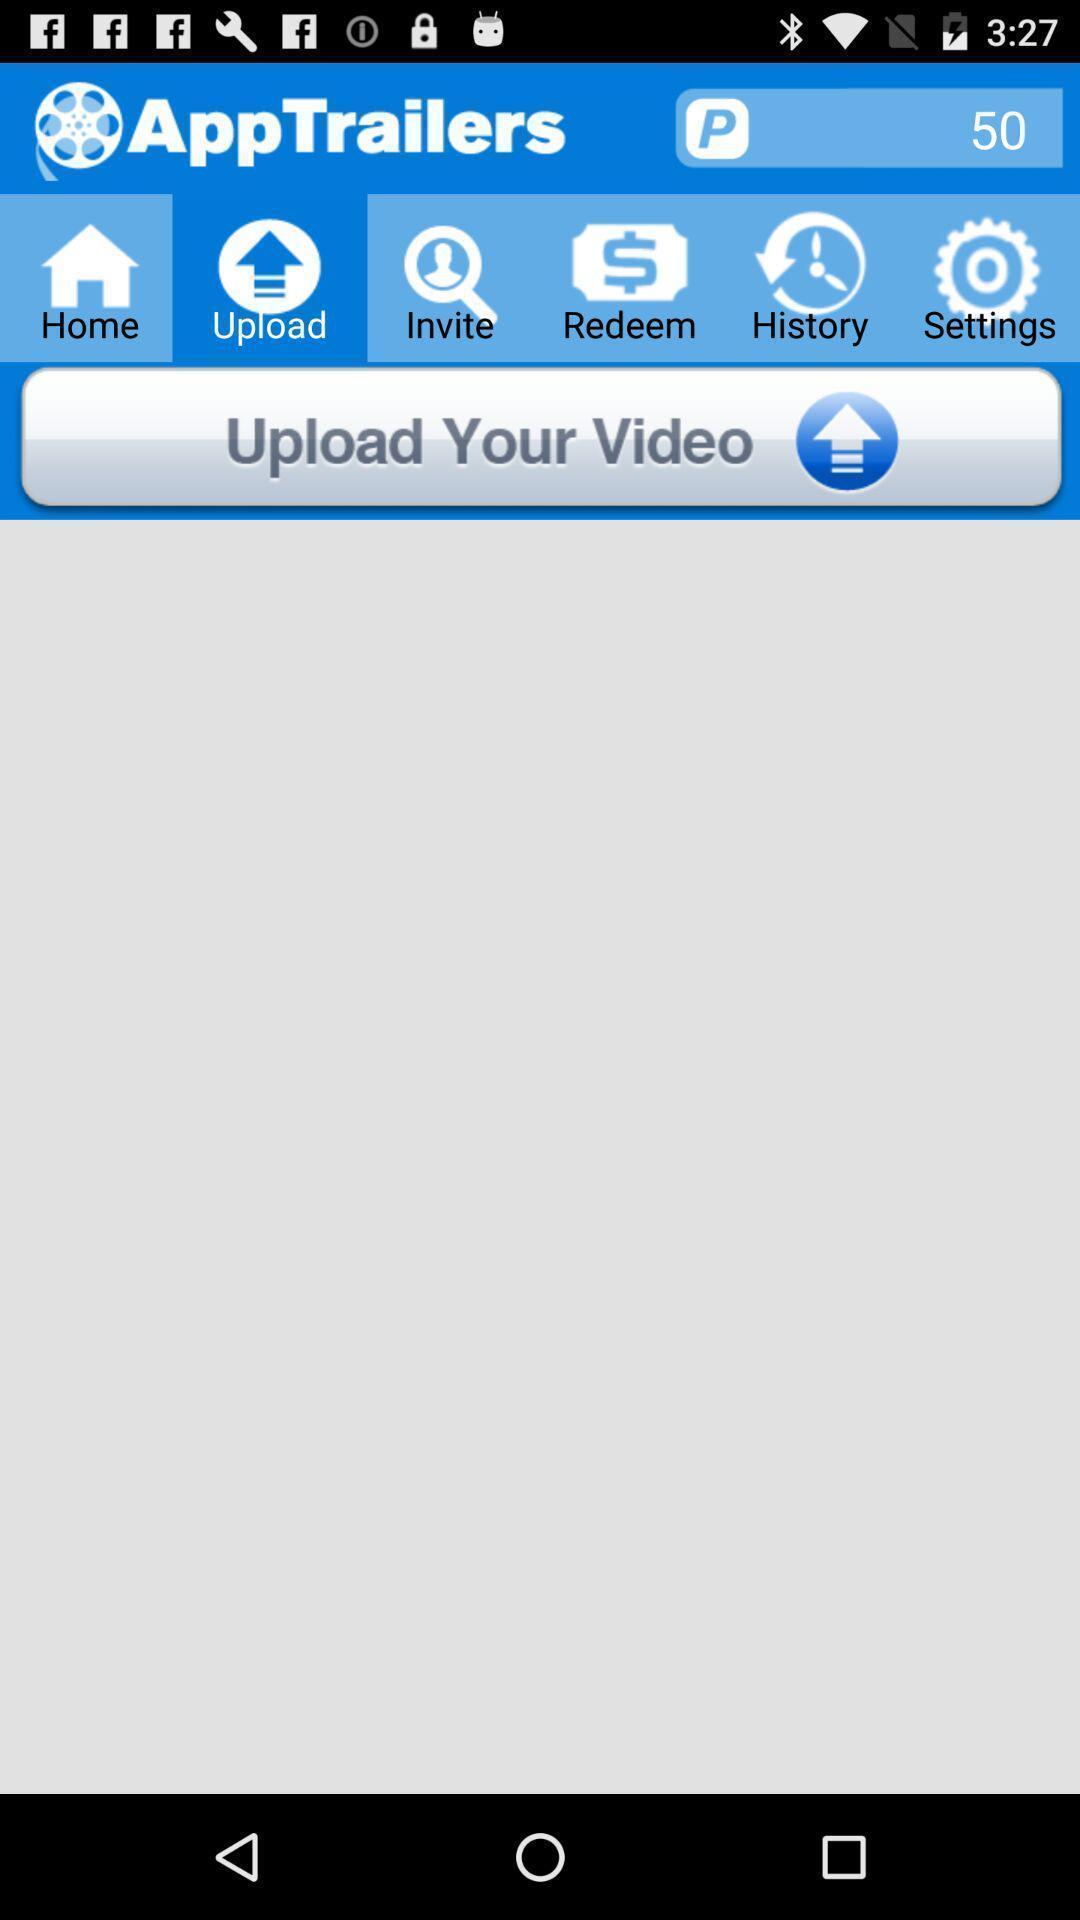Tell me about the visual elements in this screen capture. Upload page. 